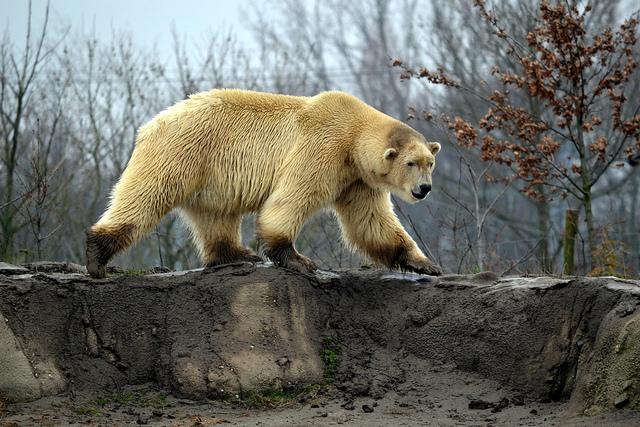Are polar bears on the endangered species list?
Concise answer only. Yes. Are the bear's feet black or muddy?
Give a very brief answer. Muddy. What kind of climate does this animal prefer?
Keep it brief. Cold. Is the bear white or yellow?
Short answer required. White. 